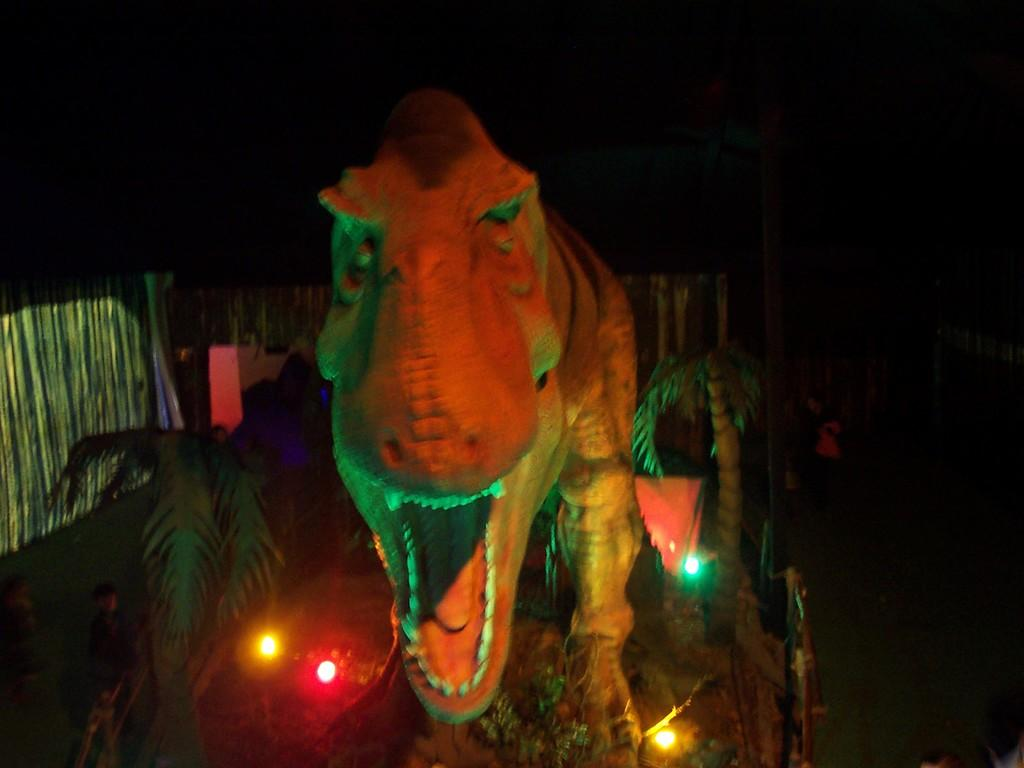What is the main subject of the image? There is a statue of a dinosaur in the image. What can be seen on the ground in the image? There are lights on the ground in the image. What type of vegetation is present on both sides of the image? There are plants on both sides of the image. What is visible in the background of the image? There is a building in the background of the image. What type of joke is the dinosaur telling in the image? There is no indication in the image that the dinosaur is telling a joke, as it is a statue and not capable of speech or humor. 